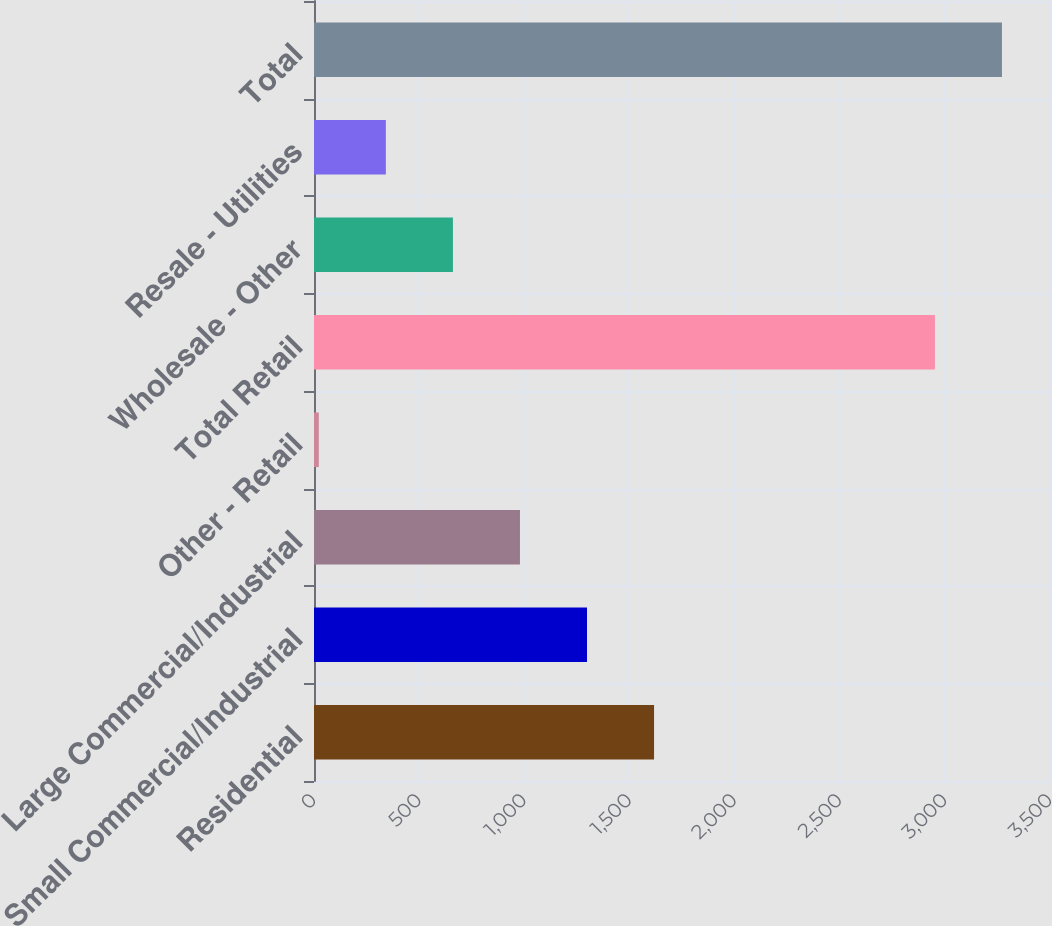Convert chart to OTSL. <chart><loc_0><loc_0><loc_500><loc_500><bar_chart><fcel>Residential<fcel>Small Commercial/Industrial<fcel>Large Commercial/Industrial<fcel>Other - Retail<fcel>Total Retail<fcel>Wholesale - Other<fcel>Resale - Utilities<fcel>Total<nl><fcel>1617.1<fcel>1298.26<fcel>979.42<fcel>22.9<fcel>2952.7<fcel>660.58<fcel>341.74<fcel>3271.54<nl></chart> 